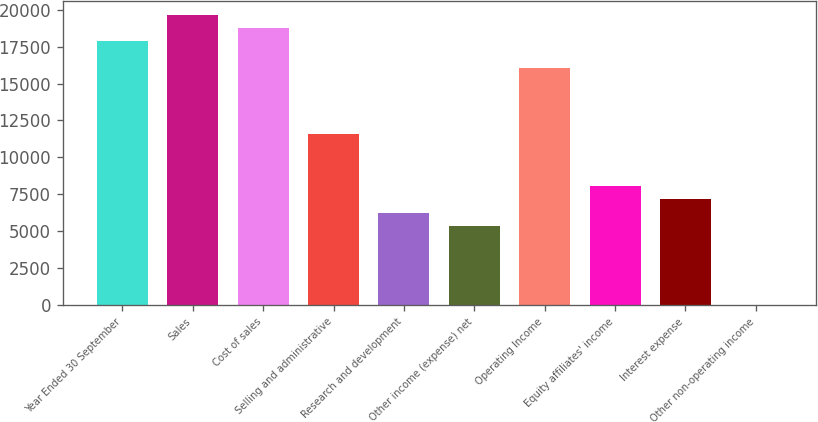Convert chart to OTSL. <chart><loc_0><loc_0><loc_500><loc_500><bar_chart><fcel>Year Ended 30 September<fcel>Sales<fcel>Cost of sales<fcel>Selling and administrative<fcel>Research and development<fcel>Other income (expense) net<fcel>Operating Income<fcel>Equity affiliates' income<fcel>Interest expense<fcel>Other non-operating income<nl><fcel>17855.3<fcel>19640.3<fcel>18747.8<fcel>11607.7<fcel>6252.67<fcel>5360.16<fcel>16070.3<fcel>8037.69<fcel>7145.18<fcel>5.1<nl></chart> 